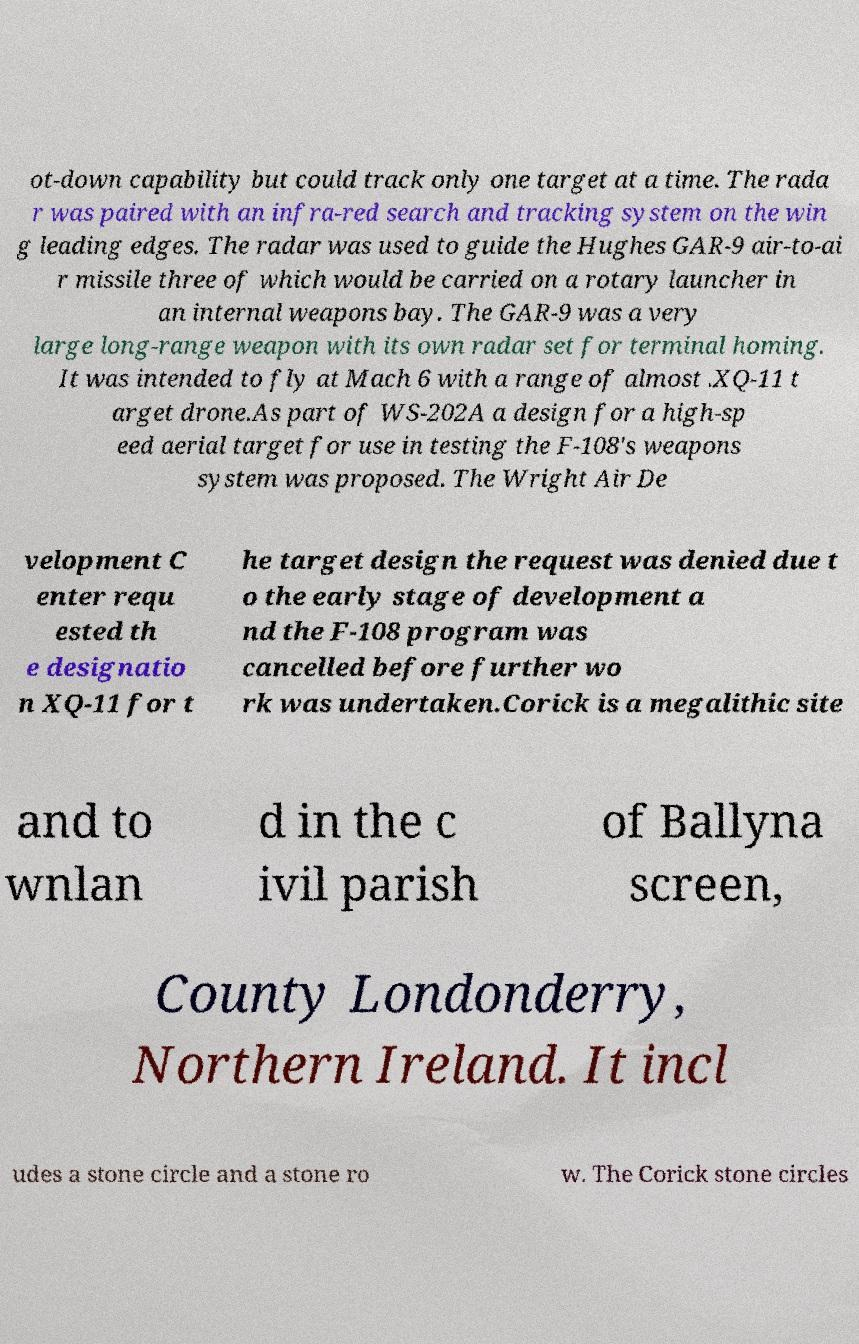What messages or text are displayed in this image? I need them in a readable, typed format. ot-down capability but could track only one target at a time. The rada r was paired with an infra-red search and tracking system on the win g leading edges. The radar was used to guide the Hughes GAR-9 air-to-ai r missile three of which would be carried on a rotary launcher in an internal weapons bay. The GAR-9 was a very large long-range weapon with its own radar set for terminal homing. It was intended to fly at Mach 6 with a range of almost .XQ-11 t arget drone.As part of WS-202A a design for a high-sp eed aerial target for use in testing the F-108's weapons system was proposed. The Wright Air De velopment C enter requ ested th e designatio n XQ-11 for t he target design the request was denied due t o the early stage of development a nd the F-108 program was cancelled before further wo rk was undertaken.Corick is a megalithic site and to wnlan d in the c ivil parish of Ballyna screen, County Londonderry, Northern Ireland. It incl udes a stone circle and a stone ro w. The Corick stone circles 